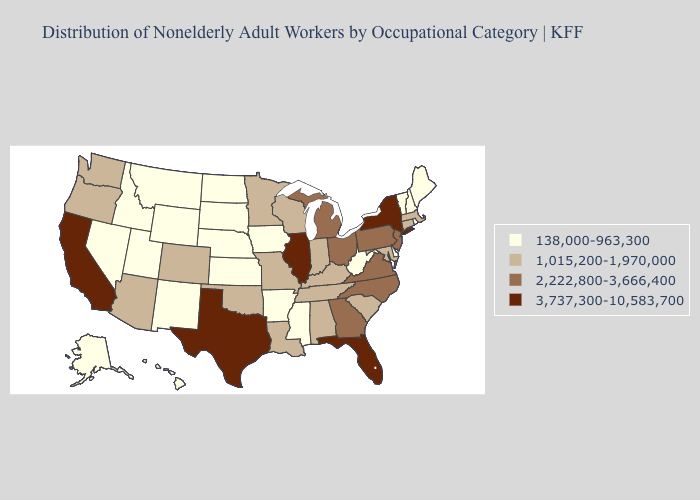Which states have the lowest value in the USA?
Short answer required. Alaska, Arkansas, Delaware, Hawaii, Idaho, Iowa, Kansas, Maine, Mississippi, Montana, Nebraska, Nevada, New Hampshire, New Mexico, North Dakota, Rhode Island, South Dakota, Utah, Vermont, West Virginia, Wyoming. What is the highest value in the South ?
Write a very short answer. 3,737,300-10,583,700. Does the first symbol in the legend represent the smallest category?
Short answer required. Yes. Does West Virginia have the highest value in the USA?
Concise answer only. No. What is the highest value in the South ?
Answer briefly. 3,737,300-10,583,700. What is the highest value in states that border Florida?
Quick response, please. 2,222,800-3,666,400. Name the states that have a value in the range 138,000-963,300?
Quick response, please. Alaska, Arkansas, Delaware, Hawaii, Idaho, Iowa, Kansas, Maine, Mississippi, Montana, Nebraska, Nevada, New Hampshire, New Mexico, North Dakota, Rhode Island, South Dakota, Utah, Vermont, West Virginia, Wyoming. What is the highest value in states that border Oregon?
Be succinct. 3,737,300-10,583,700. Does the map have missing data?
Give a very brief answer. No. What is the value of Oklahoma?
Write a very short answer. 1,015,200-1,970,000. Does Florida have the lowest value in the South?
Give a very brief answer. No. Does Tennessee have the same value as Michigan?
Concise answer only. No. What is the value of North Dakota?
Quick response, please. 138,000-963,300. Name the states that have a value in the range 138,000-963,300?
Answer briefly. Alaska, Arkansas, Delaware, Hawaii, Idaho, Iowa, Kansas, Maine, Mississippi, Montana, Nebraska, Nevada, New Hampshire, New Mexico, North Dakota, Rhode Island, South Dakota, Utah, Vermont, West Virginia, Wyoming. 